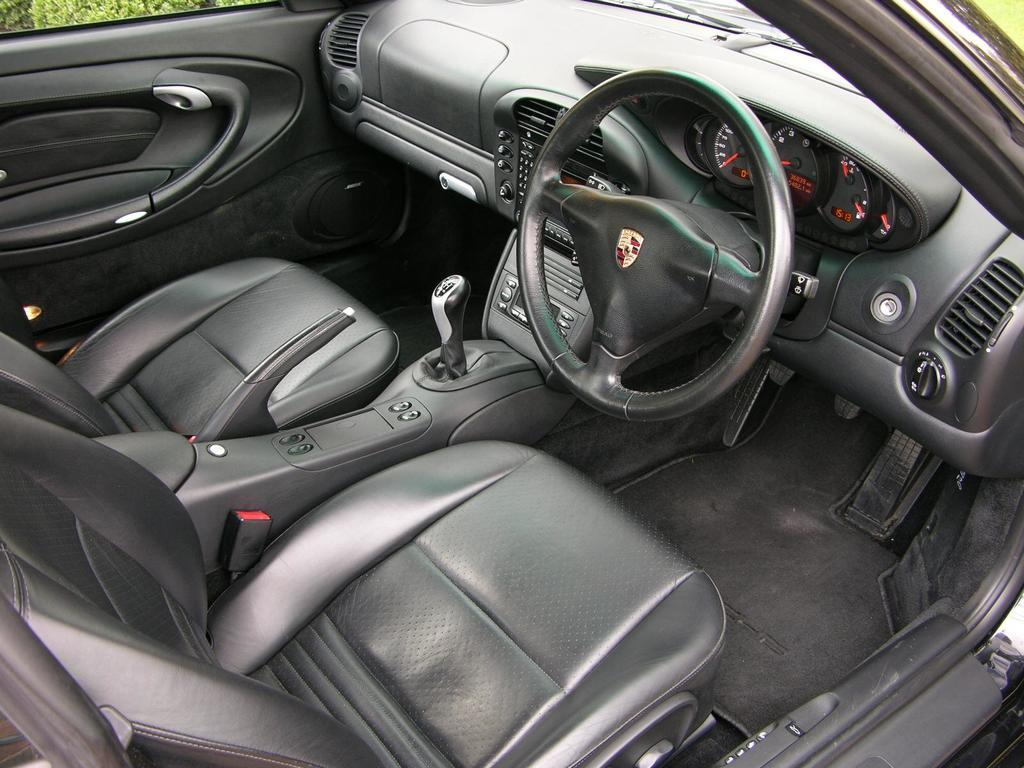What is the main subject of the image? The main subject of the image is a car. What features can be seen inside the car? The car has a steering wheel, a gear shift, and buttons. Are there any other unspecified elements inside the car? Yes, there are other unspecified elements inside the car. Can you see a donkey sitting on the back seat of the car in the image? No, there is no donkey present in the image. What color is the ball that the driver is holding in the image? There is no ball present in the image. 